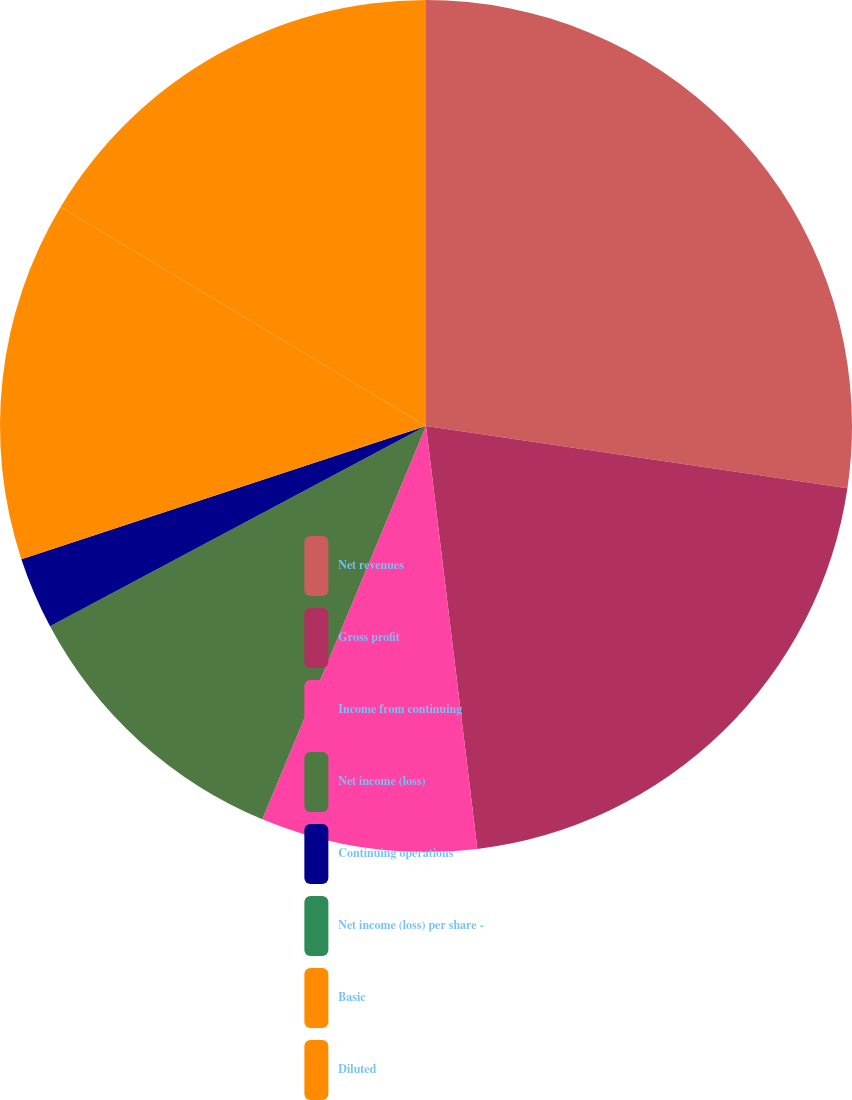Convert chart. <chart><loc_0><loc_0><loc_500><loc_500><pie_chart><fcel>Net revenues<fcel>Gross profit<fcel>Income from continuing<fcel>Net income (loss)<fcel>Continuing operations<fcel>Net income (loss) per share -<fcel>Basic<fcel>Diluted<nl><fcel>27.33%<fcel>20.74%<fcel>8.2%<fcel>10.93%<fcel>2.73%<fcel>0.0%<fcel>13.66%<fcel>16.4%<nl></chart> 